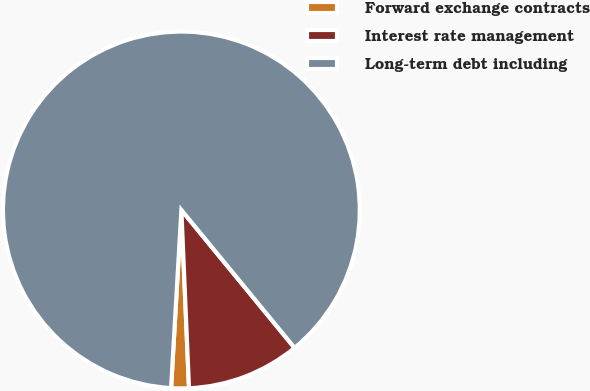<chart> <loc_0><loc_0><loc_500><loc_500><pie_chart><fcel>Forward exchange contracts<fcel>Interest rate management<fcel>Long-term debt including<nl><fcel>1.6%<fcel>10.26%<fcel>88.14%<nl></chart> 